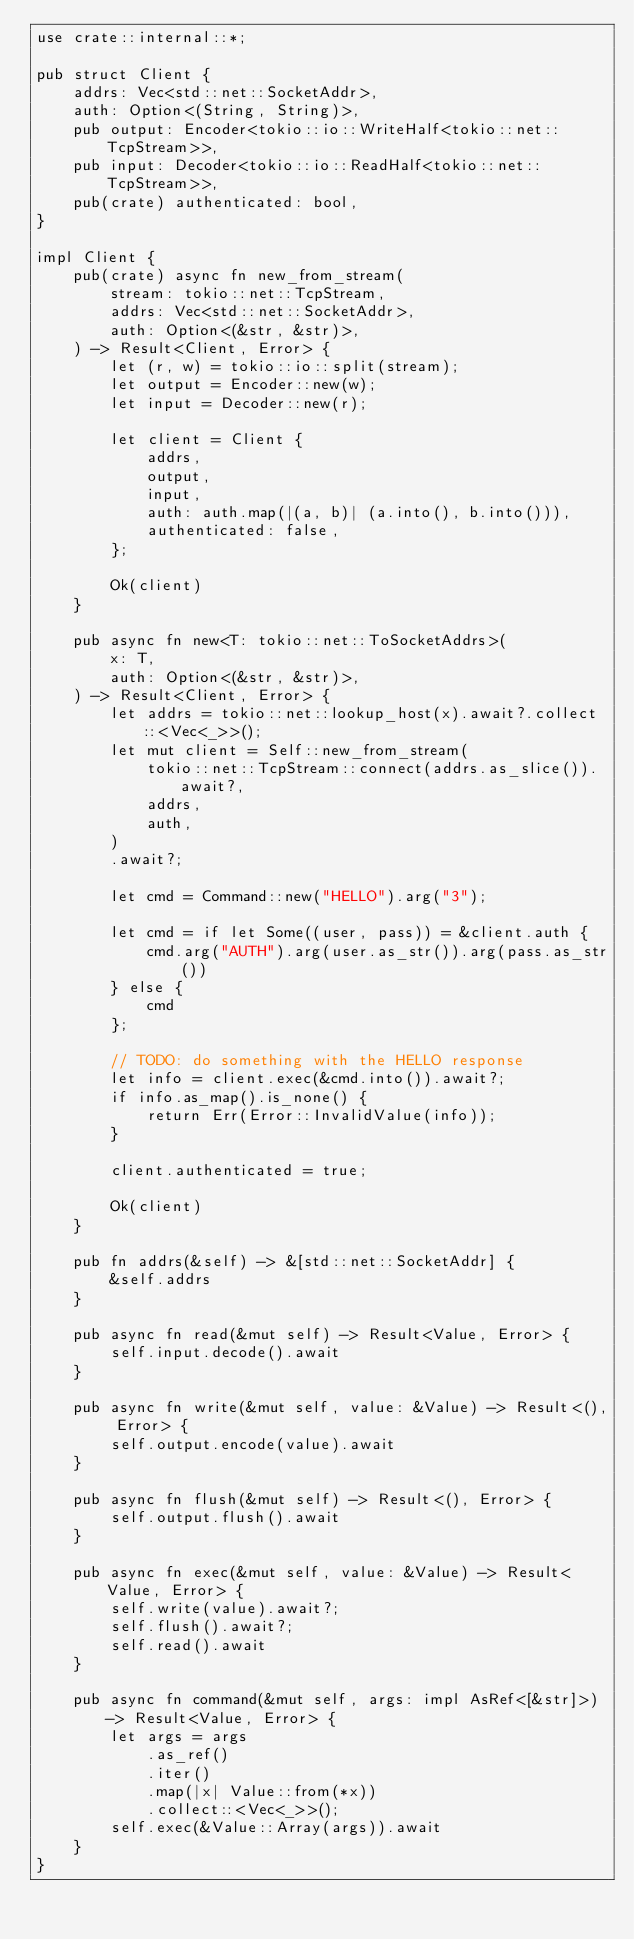Convert code to text. <code><loc_0><loc_0><loc_500><loc_500><_Rust_>use crate::internal::*;

pub struct Client {
    addrs: Vec<std::net::SocketAddr>,
    auth: Option<(String, String)>,
    pub output: Encoder<tokio::io::WriteHalf<tokio::net::TcpStream>>,
    pub input: Decoder<tokio::io::ReadHalf<tokio::net::TcpStream>>,
    pub(crate) authenticated: bool,
}

impl Client {
    pub(crate) async fn new_from_stream(
        stream: tokio::net::TcpStream,
        addrs: Vec<std::net::SocketAddr>,
        auth: Option<(&str, &str)>,
    ) -> Result<Client, Error> {
        let (r, w) = tokio::io::split(stream);
        let output = Encoder::new(w);
        let input = Decoder::new(r);

        let client = Client {
            addrs,
            output,
            input,
            auth: auth.map(|(a, b)| (a.into(), b.into())),
            authenticated: false,
        };

        Ok(client)
    }

    pub async fn new<T: tokio::net::ToSocketAddrs>(
        x: T,
        auth: Option<(&str, &str)>,
    ) -> Result<Client, Error> {
        let addrs = tokio::net::lookup_host(x).await?.collect::<Vec<_>>();
        let mut client = Self::new_from_stream(
            tokio::net::TcpStream::connect(addrs.as_slice()).await?,
            addrs,
            auth,
        )
        .await?;

        let cmd = Command::new("HELLO").arg("3");

        let cmd = if let Some((user, pass)) = &client.auth {
            cmd.arg("AUTH").arg(user.as_str()).arg(pass.as_str())
        } else {
            cmd
        };

        // TODO: do something with the HELLO response
        let info = client.exec(&cmd.into()).await?;
        if info.as_map().is_none() {
            return Err(Error::InvalidValue(info));
        }

        client.authenticated = true;

        Ok(client)
    }

    pub fn addrs(&self) -> &[std::net::SocketAddr] {
        &self.addrs
    }

    pub async fn read(&mut self) -> Result<Value, Error> {
        self.input.decode().await
    }

    pub async fn write(&mut self, value: &Value) -> Result<(), Error> {
        self.output.encode(value).await
    }

    pub async fn flush(&mut self) -> Result<(), Error> {
        self.output.flush().await
    }

    pub async fn exec(&mut self, value: &Value) -> Result<Value, Error> {
        self.write(value).await?;
        self.flush().await?;
        self.read().await
    }

    pub async fn command(&mut self, args: impl AsRef<[&str]>) -> Result<Value, Error> {
        let args = args
            .as_ref()
            .iter()
            .map(|x| Value::from(*x))
            .collect::<Vec<_>>();
        self.exec(&Value::Array(args)).await
    }
}
</code> 